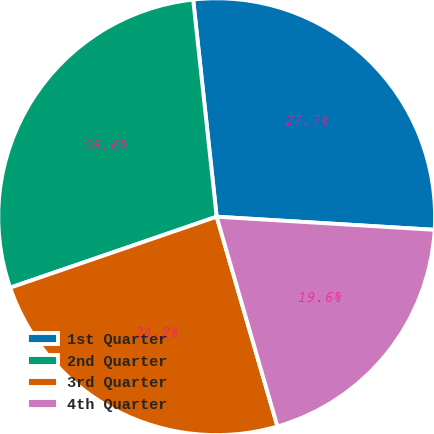<chart> <loc_0><loc_0><loc_500><loc_500><pie_chart><fcel>1st Quarter<fcel>2nd Quarter<fcel>3rd Quarter<fcel>4th Quarter<nl><fcel>27.67%<fcel>28.55%<fcel>24.22%<fcel>19.55%<nl></chart> 